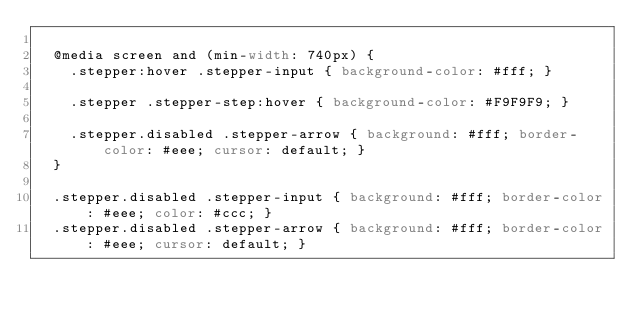<code> <loc_0><loc_0><loc_500><loc_500><_CSS_>
	@media screen and (min-width: 740px) {
		.stepper:hover .stepper-input { background-color: #fff; }

		.stepper .stepper-step:hover { background-color: #F9F9F9; }

		.stepper.disabled .stepper-arrow { background: #fff; border-color: #eee; cursor: default; }
	}

	.stepper.disabled .stepper-input { background: #fff; border-color: #eee; color: #ccc; }
	.stepper.disabled .stepper-arrow { background: #fff; border-color: #eee; cursor: default; }</code> 